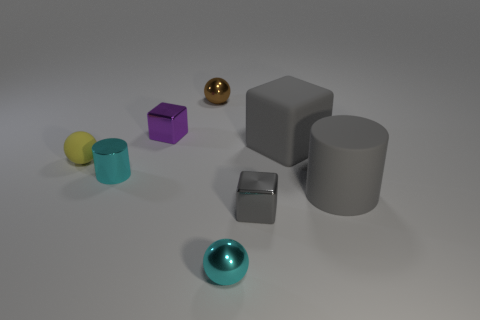Add 1 gray metallic cubes. How many objects exist? 9 Subtract all cylinders. How many objects are left? 6 Subtract 0 purple spheres. How many objects are left? 8 Subtract all blue things. Subtract all gray metallic objects. How many objects are left? 7 Add 6 tiny cylinders. How many tiny cylinders are left? 7 Add 7 large cyan shiny balls. How many large cyan shiny balls exist? 7 